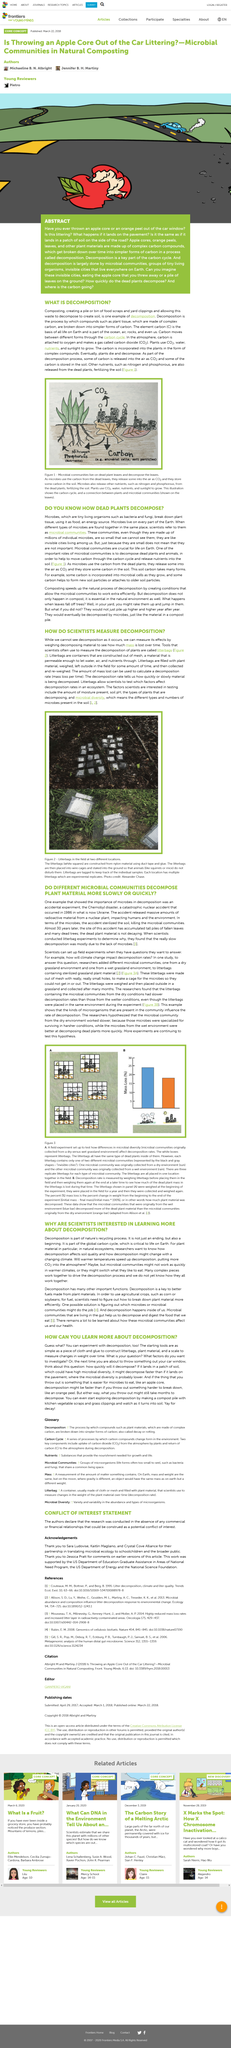List a handful of essential elements in this visual. Decomposition is a crucial component of the carbon cycle, where carbon is constantly exchanged between different reservoirs in the environment. The Chernobyl disaster occurred in 1986. The work was supported by the US Department of Education Graduate Assistance in Areas of National Need Program, the US Department of Energy, and the National Science Foundation, as stated in the acknowledgments. Decomposition is a complex process that involves the cooperation of multiple components in order to achieve its outcome. Despite our current understanding, the specific mechanisms by which these components interact and drive the decomposition process remain a subject of ongoing investigation. The carbon cycle involves the movement of carbon between different forms, such as carbon dioxide in the atmosphere, carbon in plants, and carbon in the soil. 